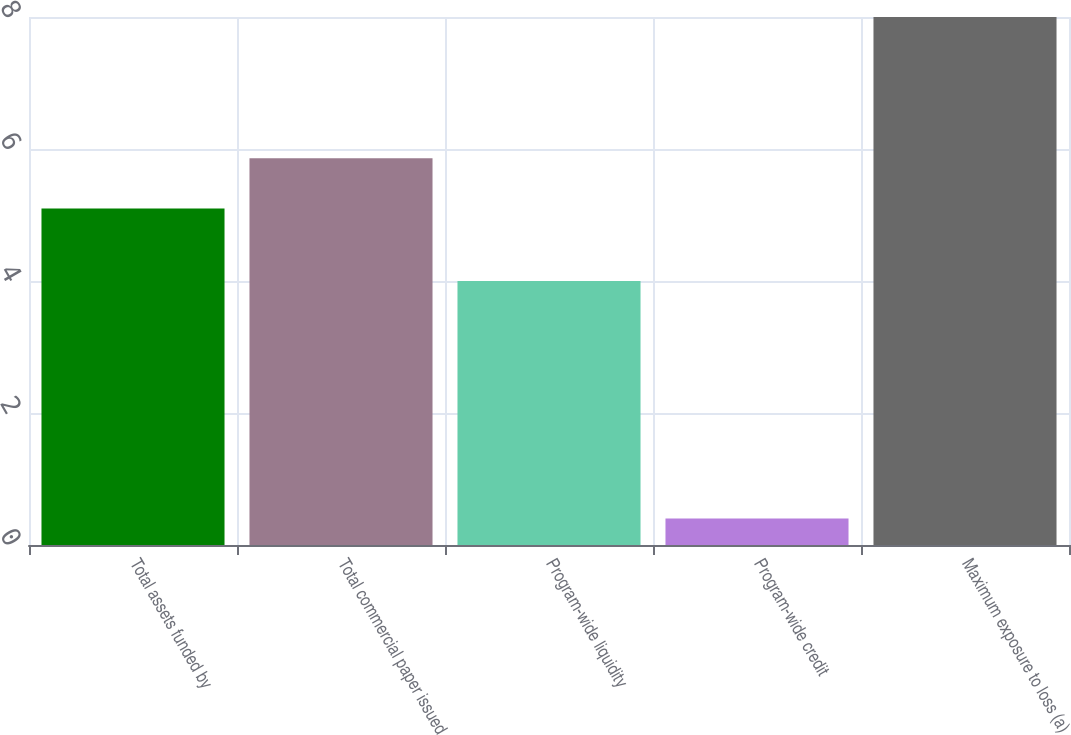<chart> <loc_0><loc_0><loc_500><loc_500><bar_chart><fcel>Total assets funded by<fcel>Total commercial paper issued<fcel>Program-wide liquidity<fcel>Program-wide credit<fcel>Maximum exposure to loss (a)<nl><fcel>5.1<fcel>5.86<fcel>4<fcel>0.4<fcel>8<nl></chart> 